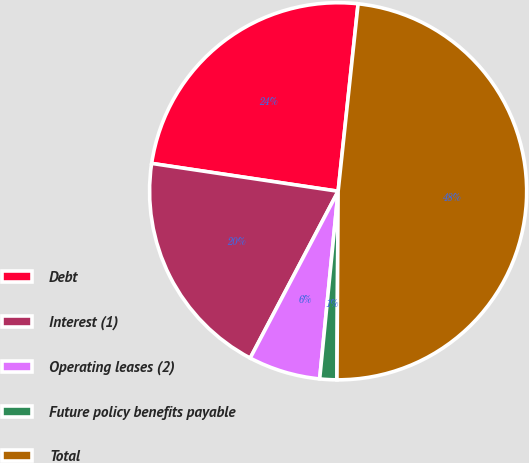Convert chart. <chart><loc_0><loc_0><loc_500><loc_500><pie_chart><fcel>Debt<fcel>Interest (1)<fcel>Operating leases (2)<fcel>Future policy benefits payable<fcel>Total<nl><fcel>24.33%<fcel>19.64%<fcel>6.16%<fcel>1.46%<fcel>48.41%<nl></chart> 